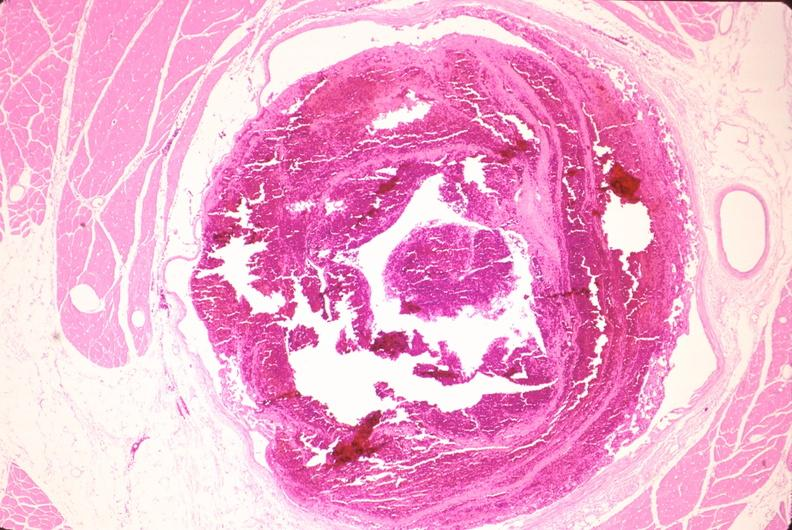does spina bifida show leg veins, thrombus?
Answer the question using a single word or phrase. No 